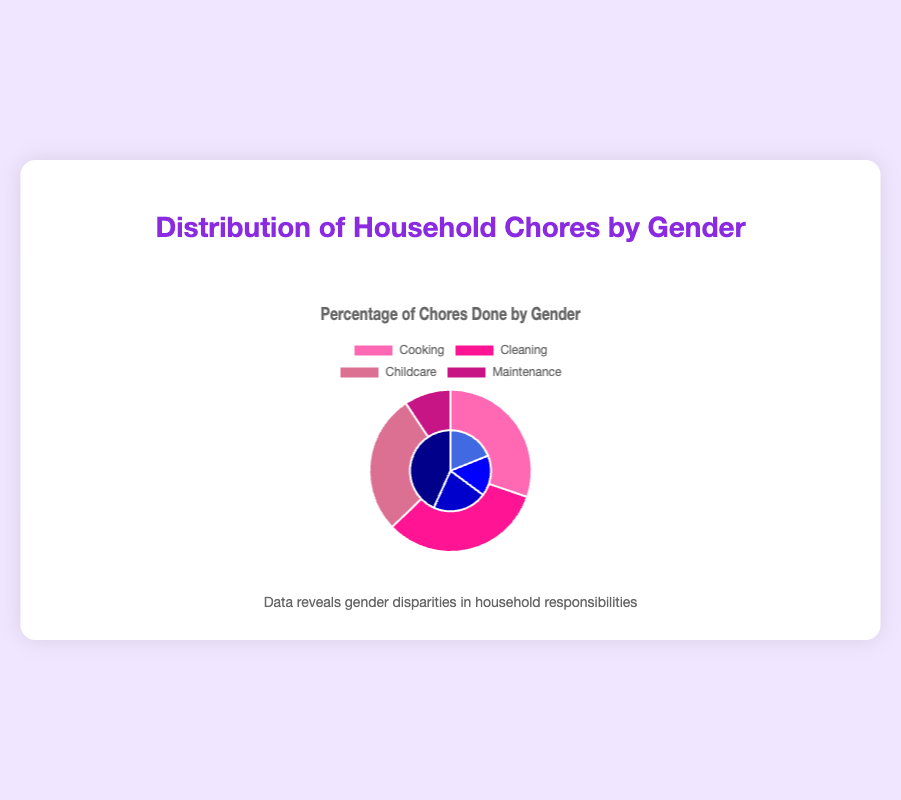Which chore has the greatest gender disparity? To determine the largest gender disparity, we look at the differences between the percentages for women and men in each chore category. The differences are as follows: Cooking (65-35=30), Cleaning (70-30=40), Childcare (60-40=20), and Maintenance (80-20=60). Maintenance has the largest disparity at 60%.
Answer: Maintenance Which chore is more equally divided between men and women? To determine the most equally divided chore, we need to find the chore with the smallest difference in percentages between men and women. The differences are as follows: Cooking (65-35=30), Cleaning (70-30=40), Childcare (60-40=20), and Maintenance (80-20=60). Childcare has the smallest difference at 20%.
Answer: Childcare What percentage of Childcare is taken up by women compared to men? The Childcare distribution is split into 60% women and 40% men. To find the percentage taken up by women compared to men, compare the two values directly.
Answer: 60% vs. 40% What is the total percentage of chores done by men? To find the total percentage of chores done by men, add up the values for all chore categories: Cooking (35), Cleaning (30), Childcare (40), Maintenance (80). The total is 35 + 30 + 40 + 80 = 185%. Since this is a breakdown across different chores, the total should be interpreted in context, not as a cumulative 100%.
Answer: 185% How does the distribution of Cooking compare between men and women? The Cooking chore distribution is 65% women and 35% men. Comparing these two values shows that women are responsible for nearly twice the percentage of cooking as men.
Answer: 65% women, 35% men Which color represents Cleaning for women, and what is its percentage? According to the dataset, Cleaning for women is represented by a distinct color in the legend (bright pink). The percentage for women in Cleaning is given as 70%.
Answer: Bright pink, 70% What is the overall pattern of chore distribution between men and women across categories? When observing the chart, the general pattern shows that women predominantly handle Cooking, Cleaning, and Childcare while men are mostly responsible for Maintenance. This indicates a significant gender disparity in household chores.
Answer: Women: Cooking, Cleaning, Childcare; Men: Maintenance If the proportion of Childcare done by men increases by 10%, what would be the new distribution? Currently, men handle 40% of Childcare. If this increases by 10%, the new distribution for men would be 50%. Since this would likely take away from the women's proportion, their new percentage would be 60% - 10% = 50%.
Answer: 50% women, 50% men What is the difference in the percentage of Cleaning done by women and men? The percentage for women in Cleaning is 70%, and for men, it is 30%. The difference is calculated as 70 - 30 = 40%.
Answer: 40% 